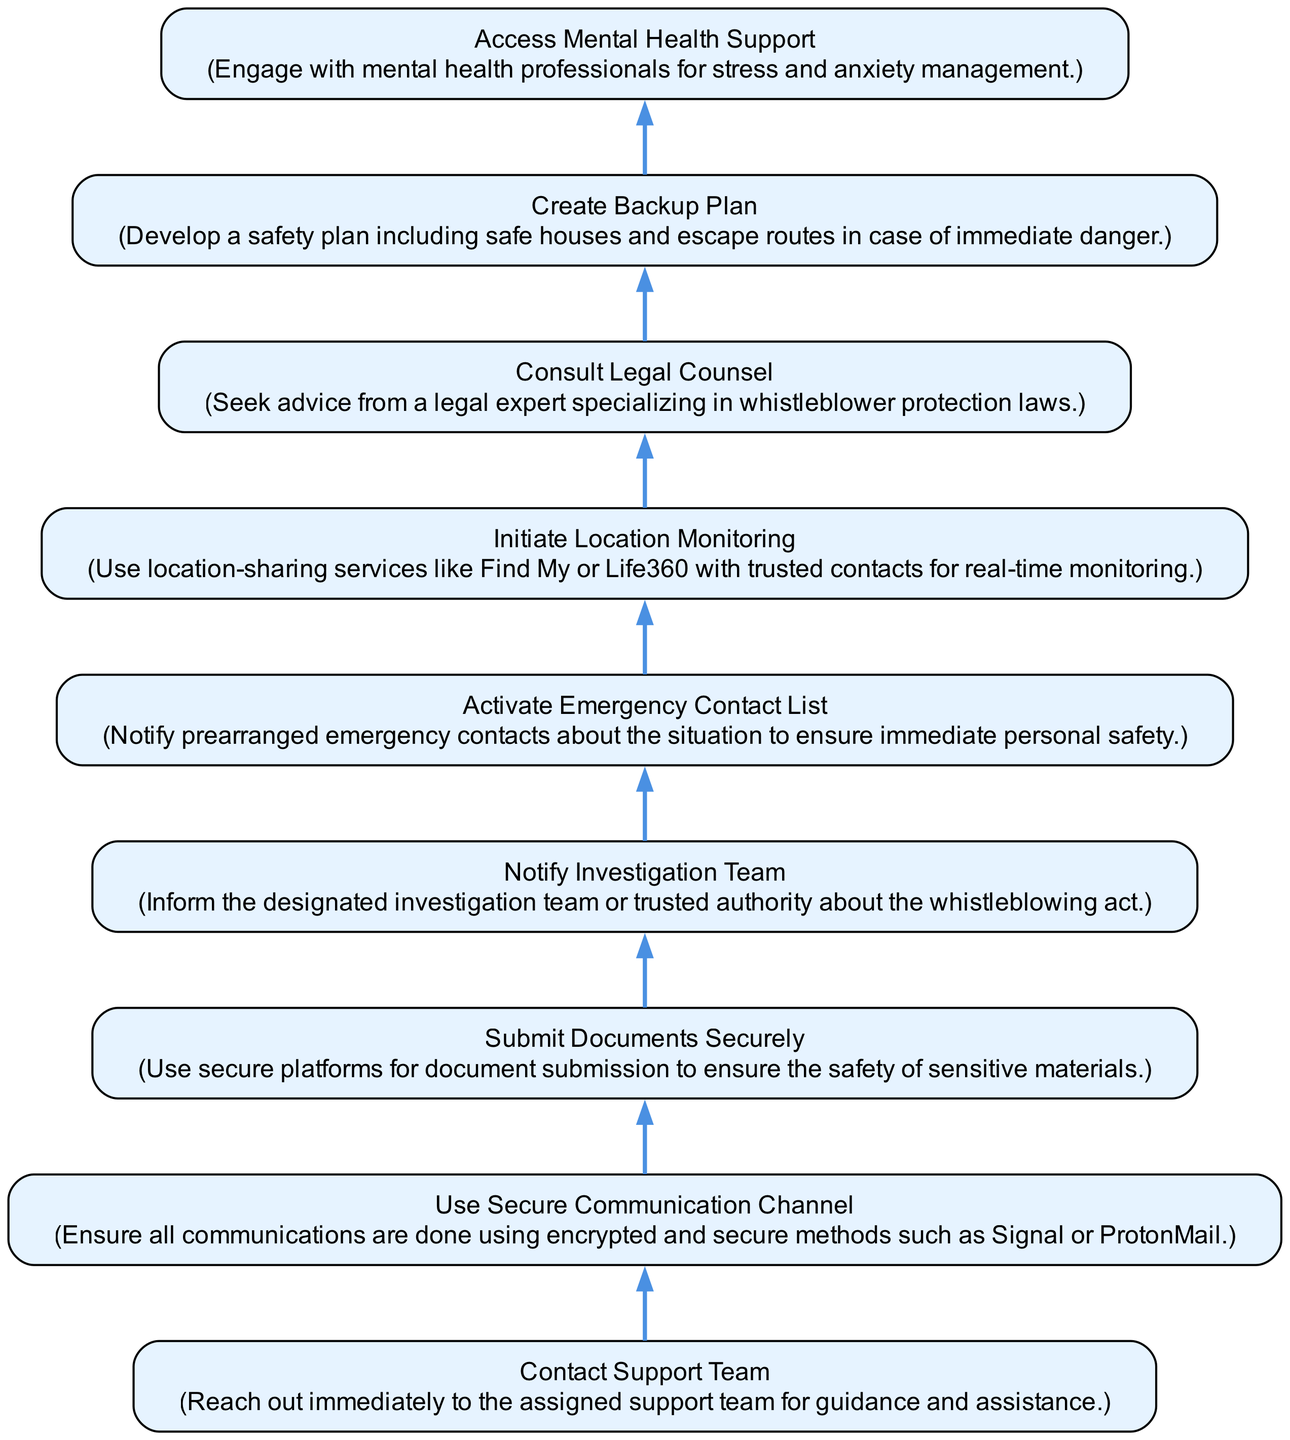what is the first step in the protocol? The first step in the protocol, as indicated at the bottom of the flow chart, is to "Contact Support Team". This is the initial action that the whistleblower should take to seek guidance and assistance.
Answer: Contact Support Team how many nodes are there in the diagram? To determine the number of nodes, I count all unique actions represented in the flow chart. There are eight nodes total that describe different steps in the emergency communication protocol.
Answer: 8 what follows after notifying the investigation team? After "Notify Investigation Team", the next step in the flow chart is "Activate Emergency Contact List." This shows the progression of actions that need to be taken in sequence.
Answer: Activate Emergency Contact List which node comes before accessing mental health support? The node that comes immediately before "Access Mental Health Support" is "Create Backup Plan". The flow indicates that one should prepare a backup plan prior to seeking mental health support.
Answer: Create Backup Plan what action is recommended before submitting documents securely? Before "Submit Documents Securely", it is essential to "Use Secure Communication Channel". This highlights the importance of ensuring secure communication methods prior to document submission.
Answer: Use Secure Communication Channel what is the final action in the protocol? The final action indicated in the protocol is "Access Mental Health Support". This is the last step in the flow chart, emphasizing ongoing mental health care after the preceding steps have been completed.
Answer: Access Mental Health Support how many edges connect the nodes on the diagram? Each edge represents a directional flow between nodes. By counting all the connections illustrated in the flow chart, there are seven edges between the eight nodes.
Answer: 7 which node indicates the use of location-monitoring services? The node that indicates the use of location-monitoring services is "Initiate Location Monitoring". This step stresses the importance of real-time location sharing for safety.
Answer: Initiate Location Monitoring what must be done after activating the emergency contacts? After "Activate Emergency Contact List", the subsequent action is "Initiate Location Monitoring." This signifies the need to start monitoring your location when emergency contacts are alerted.
Answer: Initiate Location Monitoring 